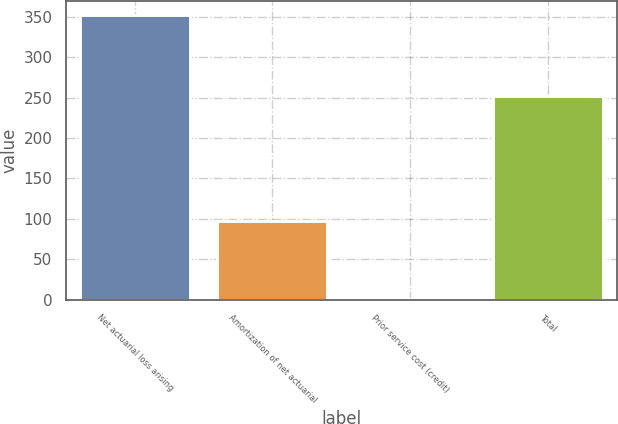Convert chart. <chart><loc_0><loc_0><loc_500><loc_500><bar_chart><fcel>Net actuarial loss arising<fcel>Amortization of net actuarial<fcel>Prior service cost (credit)<fcel>Total<nl><fcel>351.8<fcel>97.8<fcel>1.2<fcel>252.4<nl></chart> 